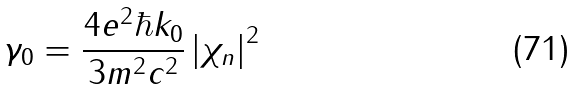Convert formula to latex. <formula><loc_0><loc_0><loc_500><loc_500>\gamma _ { 0 } = \frac { 4 e ^ { 2 } \hbar { k } _ { 0 } } { 3 m ^ { 2 } c ^ { 2 } } \left | \chi _ { n } \right | ^ { 2 }</formula> 